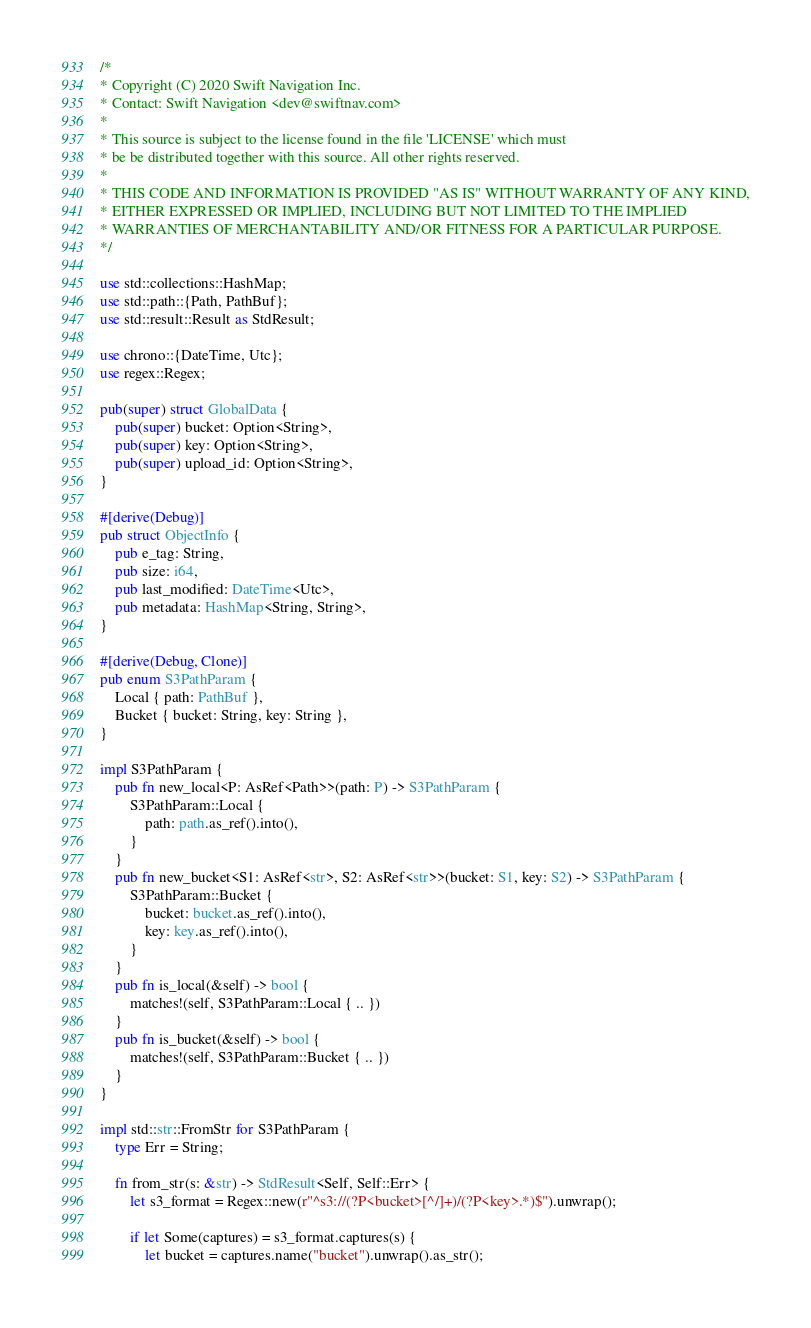Convert code to text. <code><loc_0><loc_0><loc_500><loc_500><_Rust_>/*
* Copyright (C) 2020 Swift Navigation Inc.
* Contact: Swift Navigation <dev@swiftnav.com>
*
* This source is subject to the license found in the file 'LICENSE' which must
* be be distributed together with this source. All other rights reserved.
*
* THIS CODE AND INFORMATION IS PROVIDED "AS IS" WITHOUT WARRANTY OF ANY KIND,
* EITHER EXPRESSED OR IMPLIED, INCLUDING BUT NOT LIMITED TO THE IMPLIED
* WARRANTIES OF MERCHANTABILITY AND/OR FITNESS FOR A PARTICULAR PURPOSE.
*/

use std::collections::HashMap;
use std::path::{Path, PathBuf};
use std::result::Result as StdResult;

use chrono::{DateTime, Utc};
use regex::Regex;

pub(super) struct GlobalData {
    pub(super) bucket: Option<String>,
    pub(super) key: Option<String>,
    pub(super) upload_id: Option<String>,
}

#[derive(Debug)]
pub struct ObjectInfo {
    pub e_tag: String,
    pub size: i64,
    pub last_modified: DateTime<Utc>,
    pub metadata: HashMap<String, String>,
}

#[derive(Debug, Clone)]
pub enum S3PathParam {
    Local { path: PathBuf },
    Bucket { bucket: String, key: String },
}

impl S3PathParam {
    pub fn new_local<P: AsRef<Path>>(path: P) -> S3PathParam {
        S3PathParam::Local {
            path: path.as_ref().into(),
        }
    }
    pub fn new_bucket<S1: AsRef<str>, S2: AsRef<str>>(bucket: S1, key: S2) -> S3PathParam {
        S3PathParam::Bucket {
            bucket: bucket.as_ref().into(),
            key: key.as_ref().into(),
        }
    }
    pub fn is_local(&self) -> bool {
        matches!(self, S3PathParam::Local { .. })
    }
    pub fn is_bucket(&self) -> bool {
        matches!(self, S3PathParam::Bucket { .. })
    }
}

impl std::str::FromStr for S3PathParam {
    type Err = String;

    fn from_str(s: &str) -> StdResult<Self, Self::Err> {
        let s3_format = Regex::new(r"^s3://(?P<bucket>[^/]+)/(?P<key>.*)$").unwrap();

        if let Some(captures) = s3_format.captures(s) {
            let bucket = captures.name("bucket").unwrap().as_str();</code> 